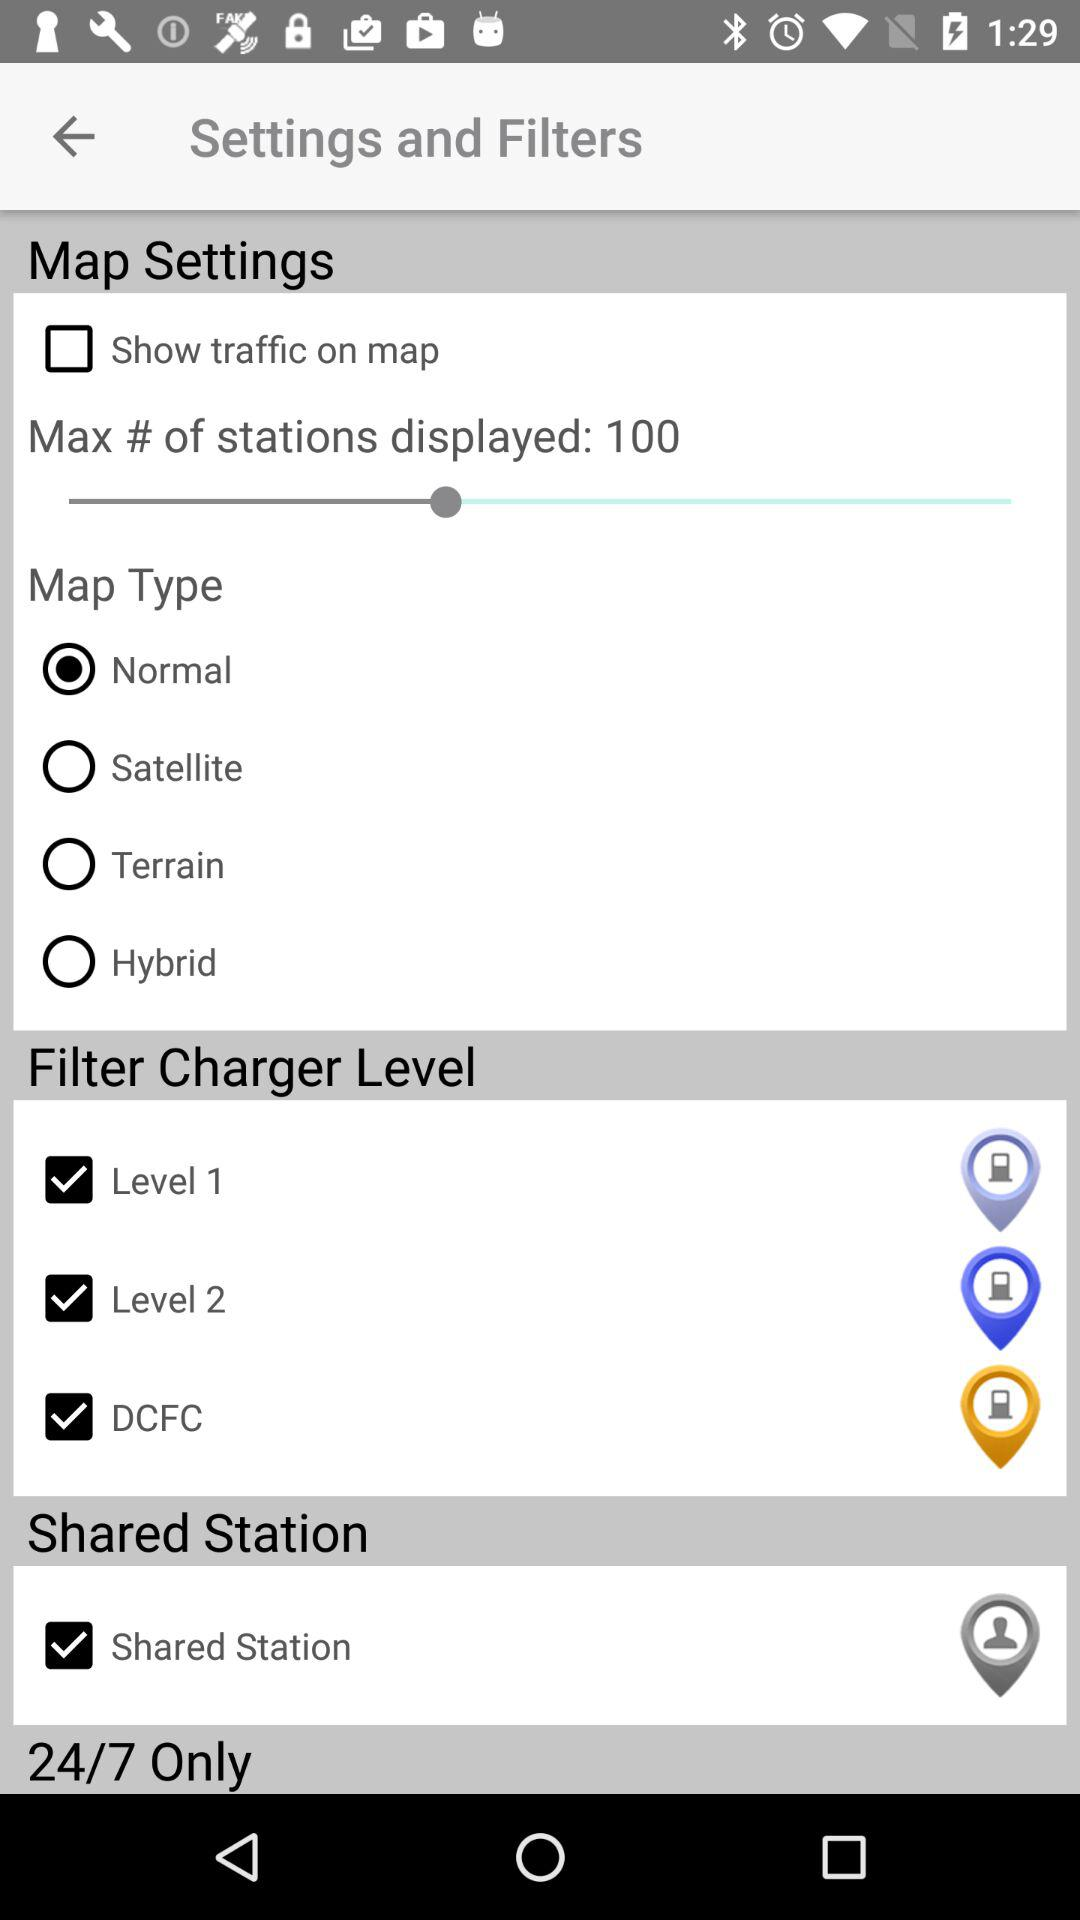What is the maximum number of stations displayed? The maximum number of stations displayed is 100. 